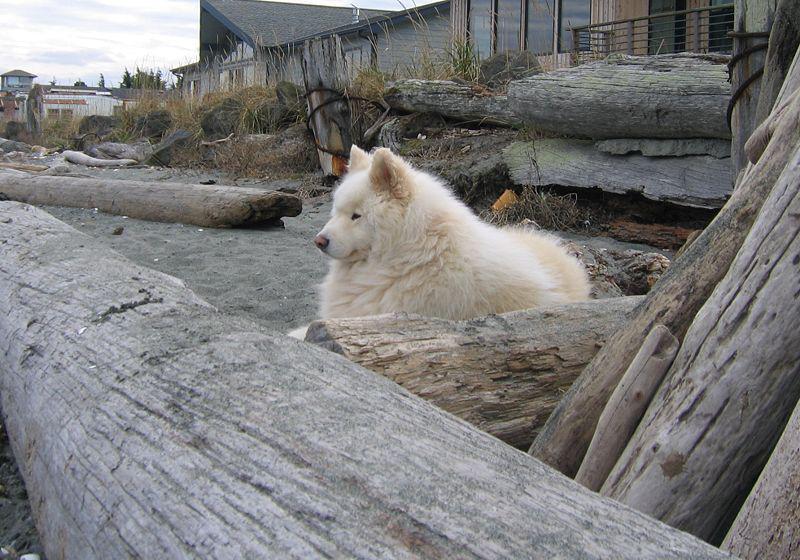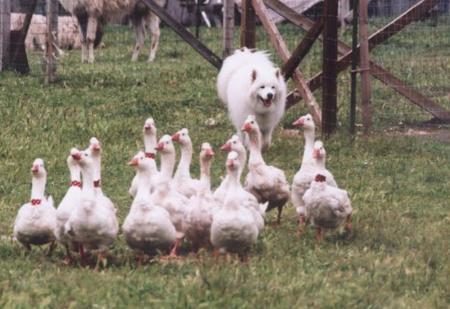The first image is the image on the left, the second image is the image on the right. For the images displayed, is the sentence "A white dog is in an enclosure working with sheep." factually correct? Answer yes or no. No. The first image is the image on the left, the second image is the image on the right. Examine the images to the left and right. Is the description "At least one image shows a woman holding a stick while working with sheep and dog." accurate? Answer yes or no. No. 